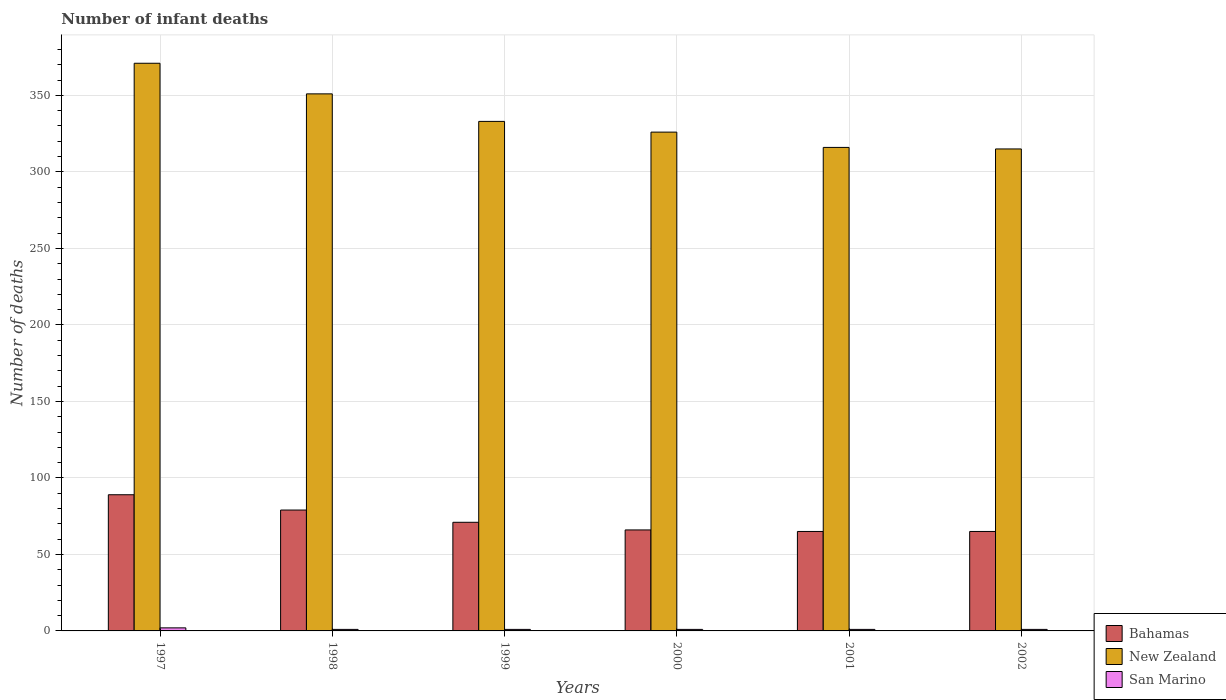How many different coloured bars are there?
Provide a short and direct response. 3. How many groups of bars are there?
Your answer should be compact. 6. Are the number of bars on each tick of the X-axis equal?
Provide a succinct answer. Yes. How many bars are there on the 5th tick from the right?
Keep it short and to the point. 3. In how many cases, is the number of bars for a given year not equal to the number of legend labels?
Ensure brevity in your answer.  0. What is the number of infant deaths in Bahamas in 1999?
Your response must be concise. 71. Across all years, what is the minimum number of infant deaths in New Zealand?
Ensure brevity in your answer.  315. In which year was the number of infant deaths in Bahamas maximum?
Make the answer very short. 1997. What is the total number of infant deaths in San Marino in the graph?
Offer a terse response. 7. What is the difference between the number of infant deaths in Bahamas in 1997 and that in 2001?
Give a very brief answer. 24. What is the difference between the number of infant deaths in Bahamas in 1998 and the number of infant deaths in San Marino in 1997?
Give a very brief answer. 77. What is the average number of infant deaths in Bahamas per year?
Offer a terse response. 72.5. In the year 2000, what is the difference between the number of infant deaths in San Marino and number of infant deaths in Bahamas?
Your answer should be very brief. -65. In how many years, is the number of infant deaths in New Zealand greater than 290?
Offer a very short reply. 6. What is the ratio of the number of infant deaths in New Zealand in 1998 to that in 1999?
Provide a succinct answer. 1.05. What is the difference between the highest and the lowest number of infant deaths in New Zealand?
Your response must be concise. 56. What does the 3rd bar from the left in 2000 represents?
Keep it short and to the point. San Marino. What does the 2nd bar from the right in 2001 represents?
Offer a terse response. New Zealand. Is it the case that in every year, the sum of the number of infant deaths in Bahamas and number of infant deaths in New Zealand is greater than the number of infant deaths in San Marino?
Give a very brief answer. Yes. Are all the bars in the graph horizontal?
Offer a very short reply. No. How many years are there in the graph?
Offer a terse response. 6. Are the values on the major ticks of Y-axis written in scientific E-notation?
Offer a very short reply. No. Does the graph contain any zero values?
Offer a very short reply. No. How many legend labels are there?
Give a very brief answer. 3. How are the legend labels stacked?
Make the answer very short. Vertical. What is the title of the graph?
Provide a succinct answer. Number of infant deaths. Does "Cuba" appear as one of the legend labels in the graph?
Offer a terse response. No. What is the label or title of the Y-axis?
Ensure brevity in your answer.  Number of deaths. What is the Number of deaths in Bahamas in 1997?
Ensure brevity in your answer.  89. What is the Number of deaths of New Zealand in 1997?
Offer a very short reply. 371. What is the Number of deaths in Bahamas in 1998?
Your response must be concise. 79. What is the Number of deaths of New Zealand in 1998?
Ensure brevity in your answer.  351. What is the Number of deaths of San Marino in 1998?
Provide a succinct answer. 1. What is the Number of deaths of Bahamas in 1999?
Give a very brief answer. 71. What is the Number of deaths of New Zealand in 1999?
Ensure brevity in your answer.  333. What is the Number of deaths in San Marino in 1999?
Provide a succinct answer. 1. What is the Number of deaths of Bahamas in 2000?
Keep it short and to the point. 66. What is the Number of deaths in New Zealand in 2000?
Your response must be concise. 326. What is the Number of deaths in New Zealand in 2001?
Your answer should be very brief. 316. What is the Number of deaths in San Marino in 2001?
Provide a short and direct response. 1. What is the Number of deaths in New Zealand in 2002?
Provide a short and direct response. 315. What is the Number of deaths in San Marino in 2002?
Your answer should be very brief. 1. Across all years, what is the maximum Number of deaths in Bahamas?
Make the answer very short. 89. Across all years, what is the maximum Number of deaths of New Zealand?
Offer a terse response. 371. Across all years, what is the minimum Number of deaths in New Zealand?
Give a very brief answer. 315. Across all years, what is the minimum Number of deaths in San Marino?
Offer a terse response. 1. What is the total Number of deaths in Bahamas in the graph?
Make the answer very short. 435. What is the total Number of deaths of New Zealand in the graph?
Make the answer very short. 2012. What is the total Number of deaths in San Marino in the graph?
Give a very brief answer. 7. What is the difference between the Number of deaths of Bahamas in 1997 and that in 1998?
Your answer should be compact. 10. What is the difference between the Number of deaths in Bahamas in 1997 and that in 1999?
Give a very brief answer. 18. What is the difference between the Number of deaths of New Zealand in 1997 and that in 1999?
Ensure brevity in your answer.  38. What is the difference between the Number of deaths in San Marino in 1997 and that in 1999?
Give a very brief answer. 1. What is the difference between the Number of deaths of Bahamas in 1997 and that in 2000?
Ensure brevity in your answer.  23. What is the difference between the Number of deaths of New Zealand in 1997 and that in 2000?
Your answer should be very brief. 45. What is the difference between the Number of deaths in San Marino in 1997 and that in 2000?
Give a very brief answer. 1. What is the difference between the Number of deaths of New Zealand in 1997 and that in 2001?
Give a very brief answer. 55. What is the difference between the Number of deaths in San Marino in 1997 and that in 2001?
Give a very brief answer. 1. What is the difference between the Number of deaths in Bahamas in 1998 and that in 1999?
Provide a succinct answer. 8. What is the difference between the Number of deaths of New Zealand in 1998 and that in 1999?
Your answer should be very brief. 18. What is the difference between the Number of deaths in San Marino in 1998 and that in 1999?
Your answer should be very brief. 0. What is the difference between the Number of deaths in San Marino in 1998 and that in 2000?
Make the answer very short. 0. What is the difference between the Number of deaths in New Zealand in 1998 and that in 2001?
Give a very brief answer. 35. What is the difference between the Number of deaths of Bahamas in 1998 and that in 2002?
Keep it short and to the point. 14. What is the difference between the Number of deaths in New Zealand in 1998 and that in 2002?
Provide a short and direct response. 36. What is the difference between the Number of deaths of Bahamas in 1999 and that in 2000?
Your response must be concise. 5. What is the difference between the Number of deaths of New Zealand in 1999 and that in 2000?
Provide a short and direct response. 7. What is the difference between the Number of deaths in San Marino in 1999 and that in 2001?
Your answer should be compact. 0. What is the difference between the Number of deaths in Bahamas in 1999 and that in 2002?
Your answer should be very brief. 6. What is the difference between the Number of deaths of New Zealand in 1999 and that in 2002?
Your answer should be compact. 18. What is the difference between the Number of deaths in San Marino in 2000 and that in 2001?
Keep it short and to the point. 0. What is the difference between the Number of deaths in New Zealand in 2000 and that in 2002?
Give a very brief answer. 11. What is the difference between the Number of deaths in Bahamas in 2001 and that in 2002?
Give a very brief answer. 0. What is the difference between the Number of deaths of New Zealand in 2001 and that in 2002?
Your answer should be compact. 1. What is the difference between the Number of deaths in Bahamas in 1997 and the Number of deaths in New Zealand in 1998?
Your answer should be very brief. -262. What is the difference between the Number of deaths of New Zealand in 1997 and the Number of deaths of San Marino in 1998?
Offer a very short reply. 370. What is the difference between the Number of deaths in Bahamas in 1997 and the Number of deaths in New Zealand in 1999?
Make the answer very short. -244. What is the difference between the Number of deaths of New Zealand in 1997 and the Number of deaths of San Marino in 1999?
Your answer should be compact. 370. What is the difference between the Number of deaths in Bahamas in 1997 and the Number of deaths in New Zealand in 2000?
Your answer should be compact. -237. What is the difference between the Number of deaths of Bahamas in 1997 and the Number of deaths of San Marino in 2000?
Give a very brief answer. 88. What is the difference between the Number of deaths in New Zealand in 1997 and the Number of deaths in San Marino in 2000?
Provide a short and direct response. 370. What is the difference between the Number of deaths in Bahamas in 1997 and the Number of deaths in New Zealand in 2001?
Make the answer very short. -227. What is the difference between the Number of deaths of New Zealand in 1997 and the Number of deaths of San Marino in 2001?
Keep it short and to the point. 370. What is the difference between the Number of deaths of Bahamas in 1997 and the Number of deaths of New Zealand in 2002?
Your response must be concise. -226. What is the difference between the Number of deaths of Bahamas in 1997 and the Number of deaths of San Marino in 2002?
Your response must be concise. 88. What is the difference between the Number of deaths in New Zealand in 1997 and the Number of deaths in San Marino in 2002?
Your response must be concise. 370. What is the difference between the Number of deaths of Bahamas in 1998 and the Number of deaths of New Zealand in 1999?
Your answer should be very brief. -254. What is the difference between the Number of deaths of New Zealand in 1998 and the Number of deaths of San Marino in 1999?
Your answer should be very brief. 350. What is the difference between the Number of deaths in Bahamas in 1998 and the Number of deaths in New Zealand in 2000?
Provide a succinct answer. -247. What is the difference between the Number of deaths in Bahamas in 1998 and the Number of deaths in San Marino in 2000?
Give a very brief answer. 78. What is the difference between the Number of deaths in New Zealand in 1998 and the Number of deaths in San Marino in 2000?
Your answer should be compact. 350. What is the difference between the Number of deaths of Bahamas in 1998 and the Number of deaths of New Zealand in 2001?
Give a very brief answer. -237. What is the difference between the Number of deaths in New Zealand in 1998 and the Number of deaths in San Marino in 2001?
Ensure brevity in your answer.  350. What is the difference between the Number of deaths in Bahamas in 1998 and the Number of deaths in New Zealand in 2002?
Keep it short and to the point. -236. What is the difference between the Number of deaths in Bahamas in 1998 and the Number of deaths in San Marino in 2002?
Your answer should be very brief. 78. What is the difference between the Number of deaths of New Zealand in 1998 and the Number of deaths of San Marino in 2002?
Provide a short and direct response. 350. What is the difference between the Number of deaths in Bahamas in 1999 and the Number of deaths in New Zealand in 2000?
Provide a short and direct response. -255. What is the difference between the Number of deaths of New Zealand in 1999 and the Number of deaths of San Marino in 2000?
Your answer should be compact. 332. What is the difference between the Number of deaths of Bahamas in 1999 and the Number of deaths of New Zealand in 2001?
Provide a short and direct response. -245. What is the difference between the Number of deaths in New Zealand in 1999 and the Number of deaths in San Marino in 2001?
Your answer should be compact. 332. What is the difference between the Number of deaths in Bahamas in 1999 and the Number of deaths in New Zealand in 2002?
Offer a very short reply. -244. What is the difference between the Number of deaths in New Zealand in 1999 and the Number of deaths in San Marino in 2002?
Ensure brevity in your answer.  332. What is the difference between the Number of deaths in Bahamas in 2000 and the Number of deaths in New Zealand in 2001?
Keep it short and to the point. -250. What is the difference between the Number of deaths of New Zealand in 2000 and the Number of deaths of San Marino in 2001?
Keep it short and to the point. 325. What is the difference between the Number of deaths in Bahamas in 2000 and the Number of deaths in New Zealand in 2002?
Keep it short and to the point. -249. What is the difference between the Number of deaths of New Zealand in 2000 and the Number of deaths of San Marino in 2002?
Offer a terse response. 325. What is the difference between the Number of deaths in Bahamas in 2001 and the Number of deaths in New Zealand in 2002?
Ensure brevity in your answer.  -250. What is the difference between the Number of deaths of New Zealand in 2001 and the Number of deaths of San Marino in 2002?
Offer a very short reply. 315. What is the average Number of deaths in Bahamas per year?
Your answer should be very brief. 72.5. What is the average Number of deaths in New Zealand per year?
Offer a terse response. 335.33. In the year 1997, what is the difference between the Number of deaths in Bahamas and Number of deaths in New Zealand?
Offer a terse response. -282. In the year 1997, what is the difference between the Number of deaths of Bahamas and Number of deaths of San Marino?
Ensure brevity in your answer.  87. In the year 1997, what is the difference between the Number of deaths in New Zealand and Number of deaths in San Marino?
Your answer should be very brief. 369. In the year 1998, what is the difference between the Number of deaths in Bahamas and Number of deaths in New Zealand?
Provide a succinct answer. -272. In the year 1998, what is the difference between the Number of deaths in New Zealand and Number of deaths in San Marino?
Provide a short and direct response. 350. In the year 1999, what is the difference between the Number of deaths of Bahamas and Number of deaths of New Zealand?
Keep it short and to the point. -262. In the year 1999, what is the difference between the Number of deaths in Bahamas and Number of deaths in San Marino?
Ensure brevity in your answer.  70. In the year 1999, what is the difference between the Number of deaths of New Zealand and Number of deaths of San Marino?
Your answer should be very brief. 332. In the year 2000, what is the difference between the Number of deaths in Bahamas and Number of deaths in New Zealand?
Provide a succinct answer. -260. In the year 2000, what is the difference between the Number of deaths of Bahamas and Number of deaths of San Marino?
Your answer should be very brief. 65. In the year 2000, what is the difference between the Number of deaths in New Zealand and Number of deaths in San Marino?
Keep it short and to the point. 325. In the year 2001, what is the difference between the Number of deaths of Bahamas and Number of deaths of New Zealand?
Keep it short and to the point. -251. In the year 2001, what is the difference between the Number of deaths of New Zealand and Number of deaths of San Marino?
Your answer should be compact. 315. In the year 2002, what is the difference between the Number of deaths of Bahamas and Number of deaths of New Zealand?
Your answer should be very brief. -250. In the year 2002, what is the difference between the Number of deaths in Bahamas and Number of deaths in San Marino?
Provide a succinct answer. 64. In the year 2002, what is the difference between the Number of deaths in New Zealand and Number of deaths in San Marino?
Ensure brevity in your answer.  314. What is the ratio of the Number of deaths in Bahamas in 1997 to that in 1998?
Provide a succinct answer. 1.13. What is the ratio of the Number of deaths of New Zealand in 1997 to that in 1998?
Keep it short and to the point. 1.06. What is the ratio of the Number of deaths in San Marino in 1997 to that in 1998?
Keep it short and to the point. 2. What is the ratio of the Number of deaths of Bahamas in 1997 to that in 1999?
Provide a short and direct response. 1.25. What is the ratio of the Number of deaths in New Zealand in 1997 to that in 1999?
Make the answer very short. 1.11. What is the ratio of the Number of deaths in Bahamas in 1997 to that in 2000?
Keep it short and to the point. 1.35. What is the ratio of the Number of deaths of New Zealand in 1997 to that in 2000?
Your response must be concise. 1.14. What is the ratio of the Number of deaths in San Marino in 1997 to that in 2000?
Ensure brevity in your answer.  2. What is the ratio of the Number of deaths in Bahamas in 1997 to that in 2001?
Keep it short and to the point. 1.37. What is the ratio of the Number of deaths in New Zealand in 1997 to that in 2001?
Your answer should be very brief. 1.17. What is the ratio of the Number of deaths of Bahamas in 1997 to that in 2002?
Your answer should be compact. 1.37. What is the ratio of the Number of deaths in New Zealand in 1997 to that in 2002?
Provide a succinct answer. 1.18. What is the ratio of the Number of deaths in San Marino in 1997 to that in 2002?
Keep it short and to the point. 2. What is the ratio of the Number of deaths of Bahamas in 1998 to that in 1999?
Offer a terse response. 1.11. What is the ratio of the Number of deaths of New Zealand in 1998 to that in 1999?
Provide a succinct answer. 1.05. What is the ratio of the Number of deaths in San Marino in 1998 to that in 1999?
Ensure brevity in your answer.  1. What is the ratio of the Number of deaths in Bahamas in 1998 to that in 2000?
Make the answer very short. 1.2. What is the ratio of the Number of deaths of New Zealand in 1998 to that in 2000?
Offer a very short reply. 1.08. What is the ratio of the Number of deaths in San Marino in 1998 to that in 2000?
Give a very brief answer. 1. What is the ratio of the Number of deaths in Bahamas in 1998 to that in 2001?
Provide a short and direct response. 1.22. What is the ratio of the Number of deaths of New Zealand in 1998 to that in 2001?
Keep it short and to the point. 1.11. What is the ratio of the Number of deaths of San Marino in 1998 to that in 2001?
Your answer should be compact. 1. What is the ratio of the Number of deaths in Bahamas in 1998 to that in 2002?
Ensure brevity in your answer.  1.22. What is the ratio of the Number of deaths in New Zealand in 1998 to that in 2002?
Your answer should be compact. 1.11. What is the ratio of the Number of deaths in San Marino in 1998 to that in 2002?
Your answer should be very brief. 1. What is the ratio of the Number of deaths in Bahamas in 1999 to that in 2000?
Offer a very short reply. 1.08. What is the ratio of the Number of deaths of New Zealand in 1999 to that in 2000?
Your answer should be very brief. 1.02. What is the ratio of the Number of deaths of Bahamas in 1999 to that in 2001?
Your response must be concise. 1.09. What is the ratio of the Number of deaths of New Zealand in 1999 to that in 2001?
Offer a very short reply. 1.05. What is the ratio of the Number of deaths in San Marino in 1999 to that in 2001?
Keep it short and to the point. 1. What is the ratio of the Number of deaths in Bahamas in 1999 to that in 2002?
Ensure brevity in your answer.  1.09. What is the ratio of the Number of deaths in New Zealand in 1999 to that in 2002?
Offer a terse response. 1.06. What is the ratio of the Number of deaths of San Marino in 1999 to that in 2002?
Make the answer very short. 1. What is the ratio of the Number of deaths of Bahamas in 2000 to that in 2001?
Ensure brevity in your answer.  1.02. What is the ratio of the Number of deaths of New Zealand in 2000 to that in 2001?
Make the answer very short. 1.03. What is the ratio of the Number of deaths of Bahamas in 2000 to that in 2002?
Offer a terse response. 1.02. What is the ratio of the Number of deaths of New Zealand in 2000 to that in 2002?
Your answer should be compact. 1.03. What is the ratio of the Number of deaths of San Marino in 2000 to that in 2002?
Make the answer very short. 1. What is the ratio of the Number of deaths in Bahamas in 2001 to that in 2002?
Keep it short and to the point. 1. What is the ratio of the Number of deaths in San Marino in 2001 to that in 2002?
Make the answer very short. 1. What is the difference between the highest and the second highest Number of deaths of Bahamas?
Ensure brevity in your answer.  10. What is the difference between the highest and the second highest Number of deaths of New Zealand?
Keep it short and to the point. 20. What is the difference between the highest and the lowest Number of deaths in New Zealand?
Keep it short and to the point. 56. What is the difference between the highest and the lowest Number of deaths in San Marino?
Offer a terse response. 1. 